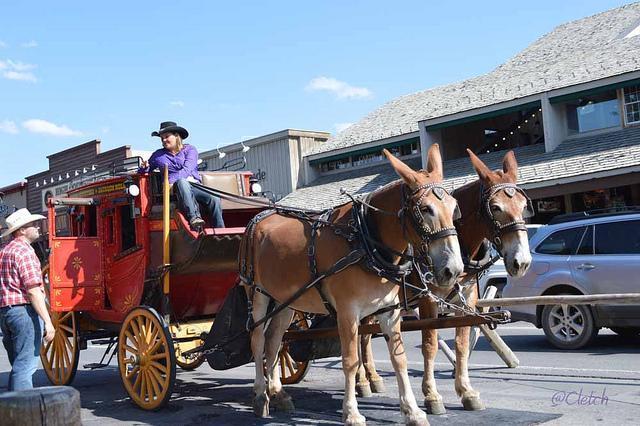How many horses are pulling the wagon?
Give a very brief answer. 2. How many horses are there?
Give a very brief answer. 2. How many people are there?
Give a very brief answer. 2. 